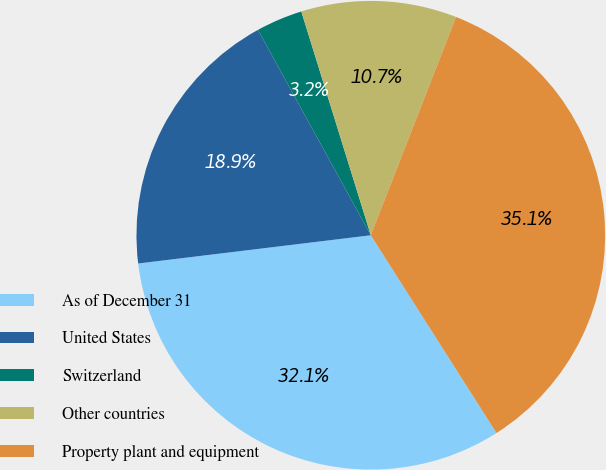Convert chart to OTSL. <chart><loc_0><loc_0><loc_500><loc_500><pie_chart><fcel>As of December 31<fcel>United States<fcel>Switzerland<fcel>Other countries<fcel>Property plant and equipment<nl><fcel>32.09%<fcel>18.93%<fcel>3.2%<fcel>10.72%<fcel>35.06%<nl></chart> 